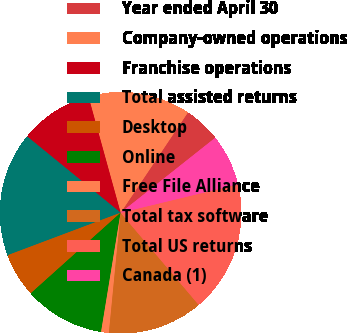Convert chart. <chart><loc_0><loc_0><loc_500><loc_500><pie_chart><fcel>Year ended April 30<fcel>Company-owned operations<fcel>Franchise operations<fcel>Total assisted returns<fcel>Desktop<fcel>Online<fcel>Free File Alliance<fcel>Total tax software<fcel>Total US returns<fcel>Canada (1)<nl><fcel>4.93%<fcel>13.7%<fcel>9.81%<fcel>16.62%<fcel>5.91%<fcel>10.78%<fcel>1.04%<fcel>12.73%<fcel>17.6%<fcel>6.88%<nl></chart> 